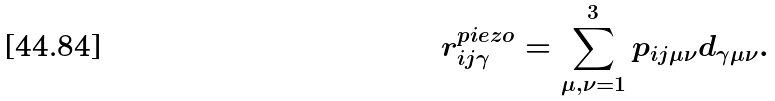Convert formula to latex. <formula><loc_0><loc_0><loc_500><loc_500>r _ { i j \gamma } ^ { p i e z o } = \sum _ { \mu , \nu = 1 } ^ { 3 } p _ { i j \mu \nu } d _ { \gamma \mu \nu } .</formula> 